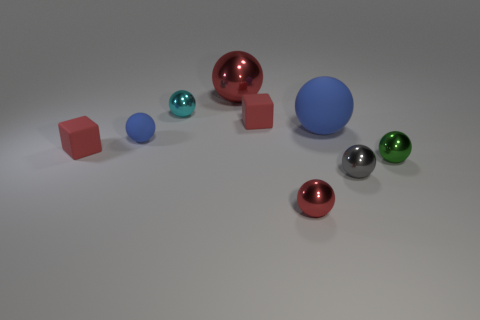Subtract all gray spheres. How many spheres are left? 6 Subtract all red shiny spheres. How many spheres are left? 5 Subtract all red balls. Subtract all cyan blocks. How many balls are left? 5 Add 1 tiny cubes. How many objects exist? 10 Subtract all balls. How many objects are left? 2 Add 7 small blocks. How many small blocks exist? 9 Subtract 0 yellow cylinders. How many objects are left? 9 Subtract all tiny gray metal balls. Subtract all rubber spheres. How many objects are left? 6 Add 7 green objects. How many green objects are left? 8 